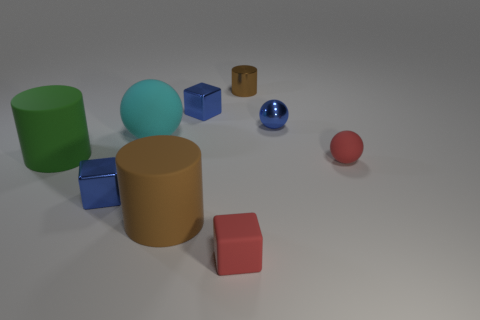Is there any other thing that has the same material as the big cyan thing? Yes, the small blue sphere near the center of the image appears to be made of the same glossy material as the large cyan cylinder. 